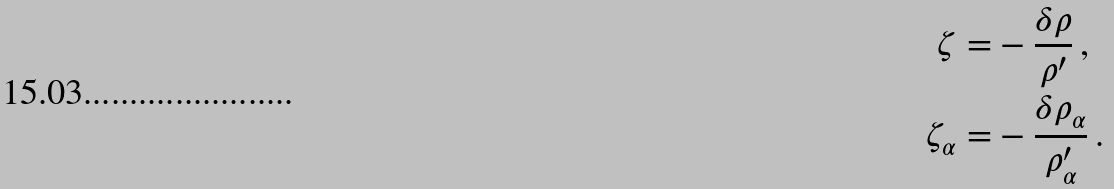<formula> <loc_0><loc_0><loc_500><loc_500>\zeta = & - \frac { \delta \rho } { \rho ^ { \prime } } \, , \\ \zeta _ { \alpha } = & - \frac { \delta \rho _ { \alpha } } { \rho _ { \alpha } ^ { \prime } } \, .</formula> 